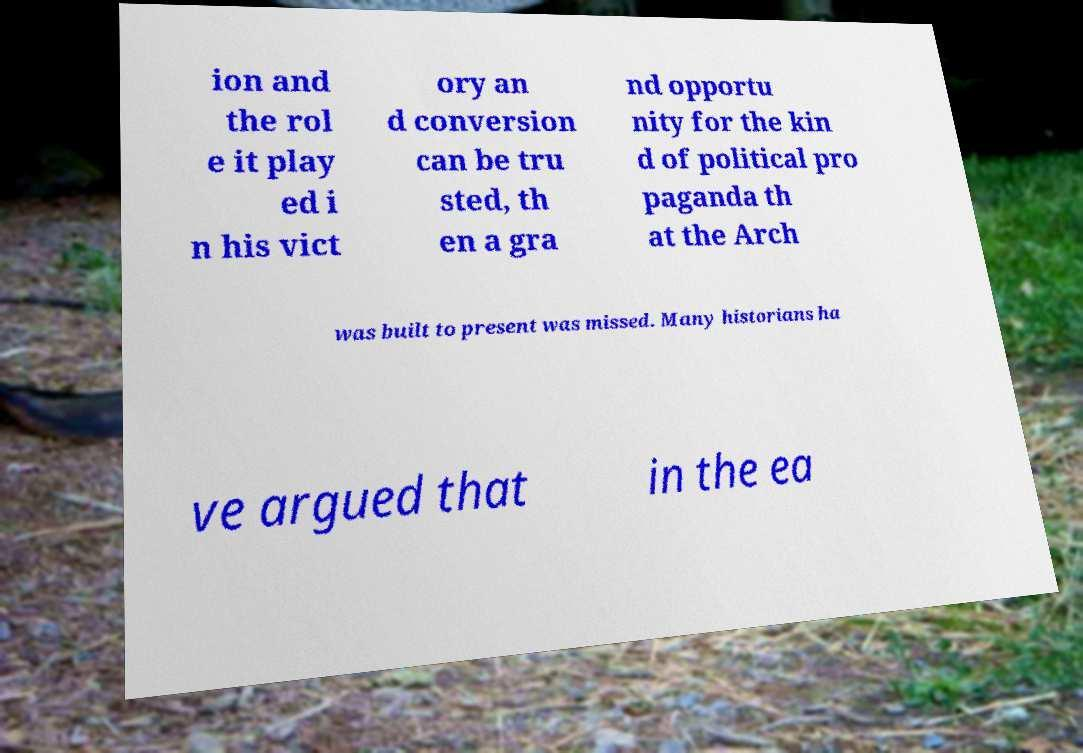There's text embedded in this image that I need extracted. Can you transcribe it verbatim? ion and the rol e it play ed i n his vict ory an d conversion can be tru sted, th en a gra nd opportu nity for the kin d of political pro paganda th at the Arch was built to present was missed. Many historians ha ve argued that in the ea 